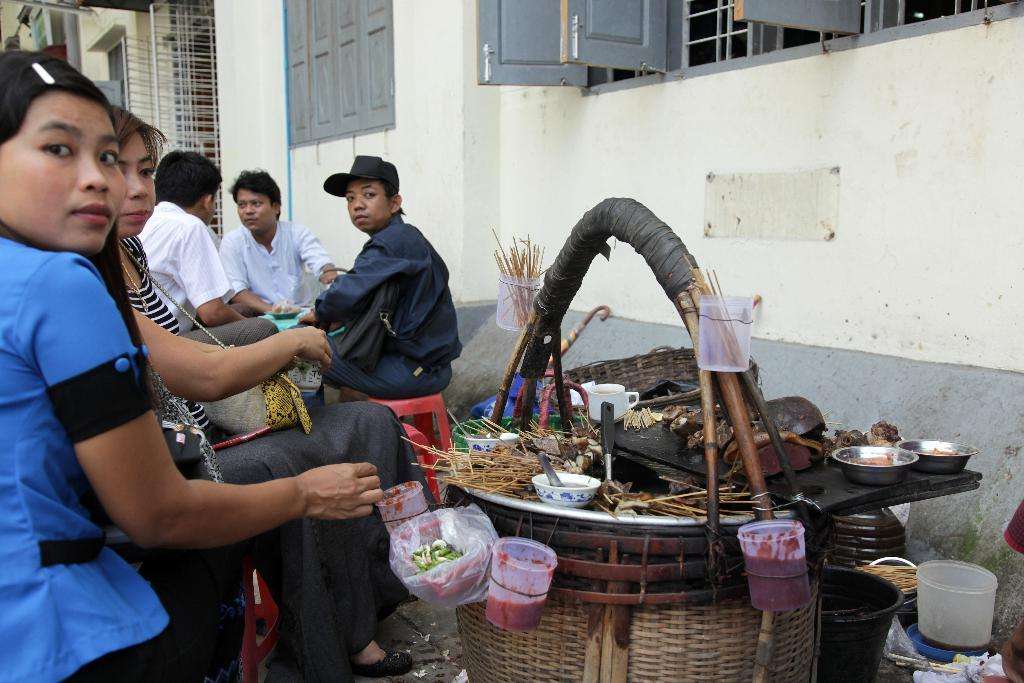What is located in the foreground of the image? There is a basket with food items and persons sitting on stools in the foreground of the image. What can be seen in the background of the image? There is a wall and a window in the background of the image. What type of plastic material is being used to create harmony among the persons in the image? There is no plastic material or reference to harmony among the persons in the image. 